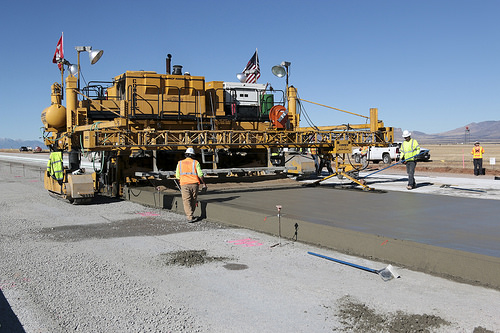<image>
Can you confirm if the man is in front of the car? No. The man is not in front of the car. The spatial positioning shows a different relationship between these objects. 